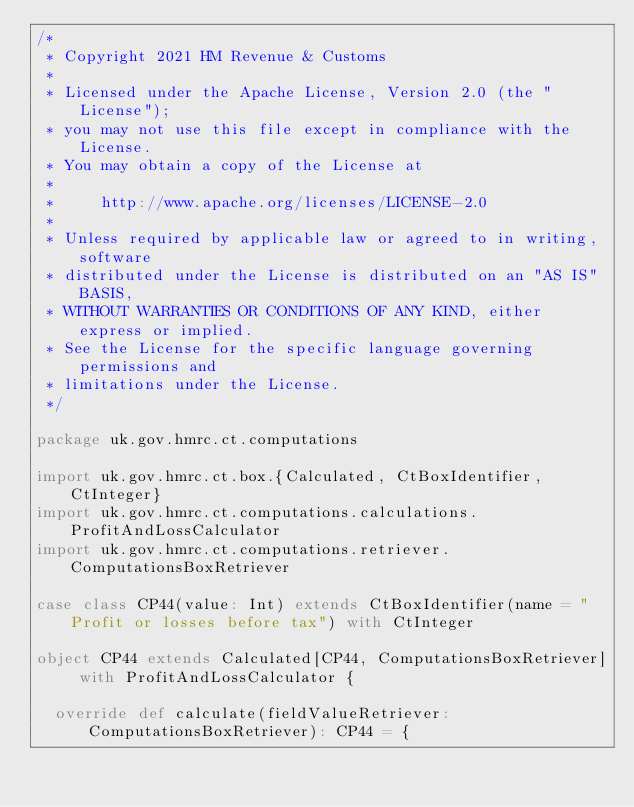Convert code to text. <code><loc_0><loc_0><loc_500><loc_500><_Scala_>/*
 * Copyright 2021 HM Revenue & Customs
 *
 * Licensed under the Apache License, Version 2.0 (the "License");
 * you may not use this file except in compliance with the License.
 * You may obtain a copy of the License at
 *
 *     http://www.apache.org/licenses/LICENSE-2.0
 *
 * Unless required by applicable law or agreed to in writing, software
 * distributed under the License is distributed on an "AS IS" BASIS,
 * WITHOUT WARRANTIES OR CONDITIONS OF ANY KIND, either express or implied.
 * See the License for the specific language governing permissions and
 * limitations under the License.
 */

package uk.gov.hmrc.ct.computations

import uk.gov.hmrc.ct.box.{Calculated, CtBoxIdentifier, CtInteger}
import uk.gov.hmrc.ct.computations.calculations.ProfitAndLossCalculator
import uk.gov.hmrc.ct.computations.retriever.ComputationsBoxRetriever

case class CP44(value: Int) extends CtBoxIdentifier(name = "Profit or losses before tax") with CtInteger

object CP44 extends Calculated[CP44, ComputationsBoxRetriever] with ProfitAndLossCalculator {

  override def calculate(fieldValueRetriever: ComputationsBoxRetriever): CP44 = {</code> 